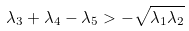<formula> <loc_0><loc_0><loc_500><loc_500>\lambda _ { 3 } + \lambda _ { 4 } - \lambda _ { 5 } > - \sqrt { \lambda _ { 1 } \lambda _ { 2 } }</formula> 